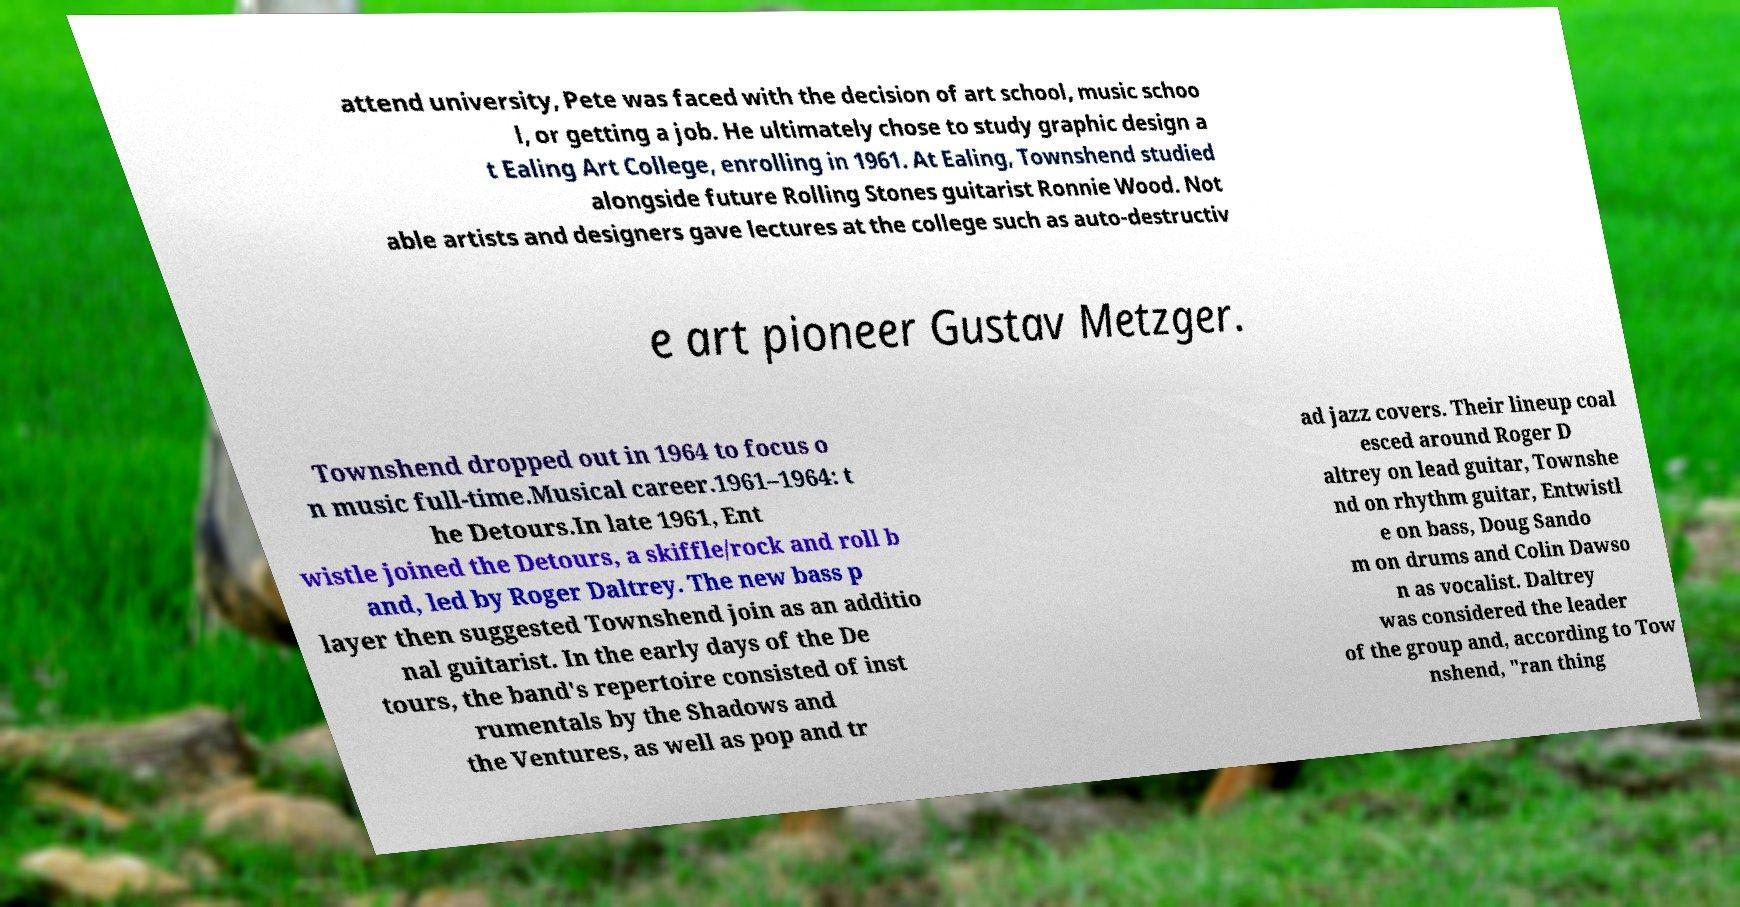Could you extract and type out the text from this image? attend university, Pete was faced with the decision of art school, music schoo l, or getting a job. He ultimately chose to study graphic design a t Ealing Art College, enrolling in 1961. At Ealing, Townshend studied alongside future Rolling Stones guitarist Ronnie Wood. Not able artists and designers gave lectures at the college such as auto-destructiv e art pioneer Gustav Metzger. Townshend dropped out in 1964 to focus o n music full-time.Musical career.1961–1964: t he Detours.In late 1961, Ent wistle joined the Detours, a skiffle/rock and roll b and, led by Roger Daltrey. The new bass p layer then suggested Townshend join as an additio nal guitarist. In the early days of the De tours, the band's repertoire consisted of inst rumentals by the Shadows and the Ventures, as well as pop and tr ad jazz covers. Their lineup coal esced around Roger D altrey on lead guitar, Townshe nd on rhythm guitar, Entwistl e on bass, Doug Sando m on drums and Colin Dawso n as vocalist. Daltrey was considered the leader of the group and, according to Tow nshend, "ran thing 